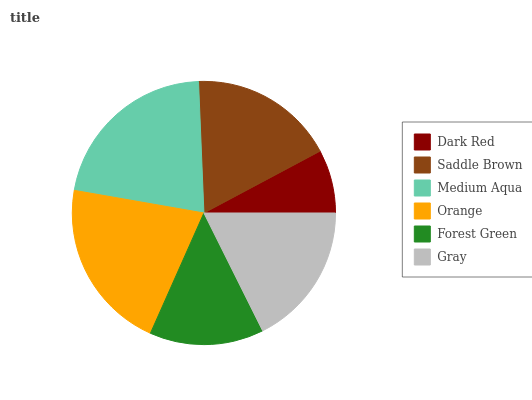Is Dark Red the minimum?
Answer yes or no. Yes. Is Medium Aqua the maximum?
Answer yes or no. Yes. Is Saddle Brown the minimum?
Answer yes or no. No. Is Saddle Brown the maximum?
Answer yes or no. No. Is Saddle Brown greater than Dark Red?
Answer yes or no. Yes. Is Dark Red less than Saddle Brown?
Answer yes or no. Yes. Is Dark Red greater than Saddle Brown?
Answer yes or no. No. Is Saddle Brown less than Dark Red?
Answer yes or no. No. Is Saddle Brown the high median?
Answer yes or no. Yes. Is Gray the low median?
Answer yes or no. Yes. Is Gray the high median?
Answer yes or no. No. Is Medium Aqua the low median?
Answer yes or no. No. 